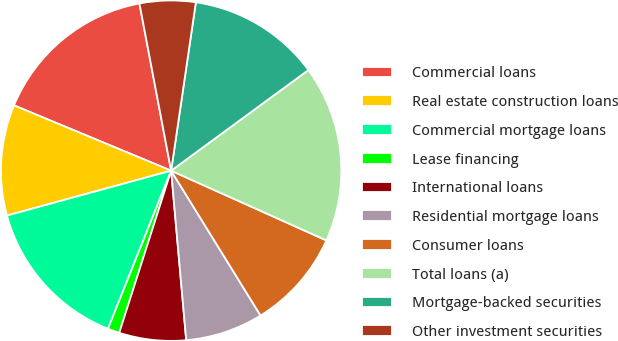Convert chart to OTSL. <chart><loc_0><loc_0><loc_500><loc_500><pie_chart><fcel>Commercial loans<fcel>Real estate construction loans<fcel>Commercial mortgage loans<fcel>Lease financing<fcel>International loans<fcel>Residential mortgage loans<fcel>Consumer loans<fcel>Total loans (a)<fcel>Mortgage-backed securities<fcel>Other investment securities<nl><fcel>15.75%<fcel>10.52%<fcel>14.7%<fcel>1.12%<fcel>6.34%<fcel>7.39%<fcel>9.48%<fcel>16.79%<fcel>12.61%<fcel>5.3%<nl></chart> 